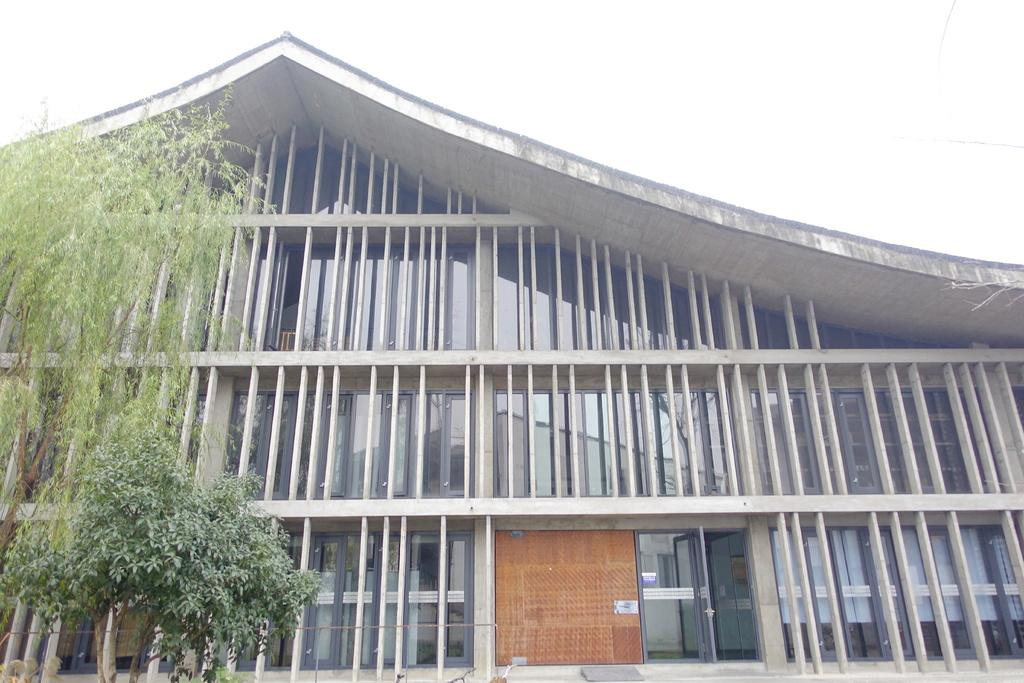What is the main structure visible in the image? There is a building in the image. What type of vegetation is present in front of the building? There are trees in front of the building. What type of string can be seen connecting the building to the hill in the image? There is no hill or string present in the image; it only features a building and trees. 